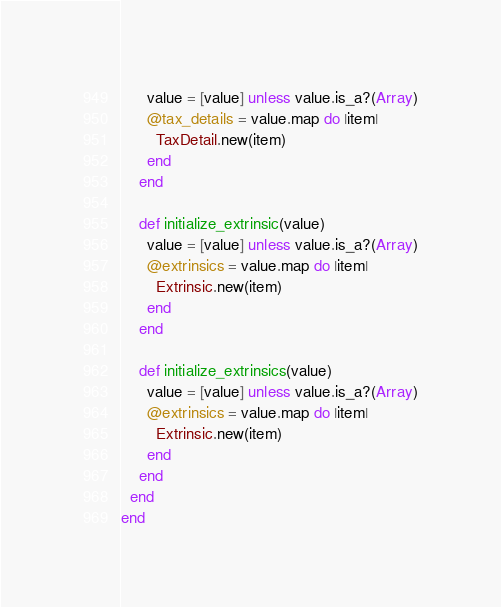<code> <loc_0><loc_0><loc_500><loc_500><_Ruby_>      value = [value] unless value.is_a?(Array)
      @tax_details = value.map do |item|
        TaxDetail.new(item)
      end
    end

    def initialize_extrinsic(value)
      value = [value] unless value.is_a?(Array)
      @extrinsics = value.map do |item|
        Extrinsic.new(item)
      end
    end

    def initialize_extrinsics(value)
      value = [value] unless value.is_a?(Array)
      @extrinsics = value.map do |item|
        Extrinsic.new(item)
      end
    end
  end
end
</code> 